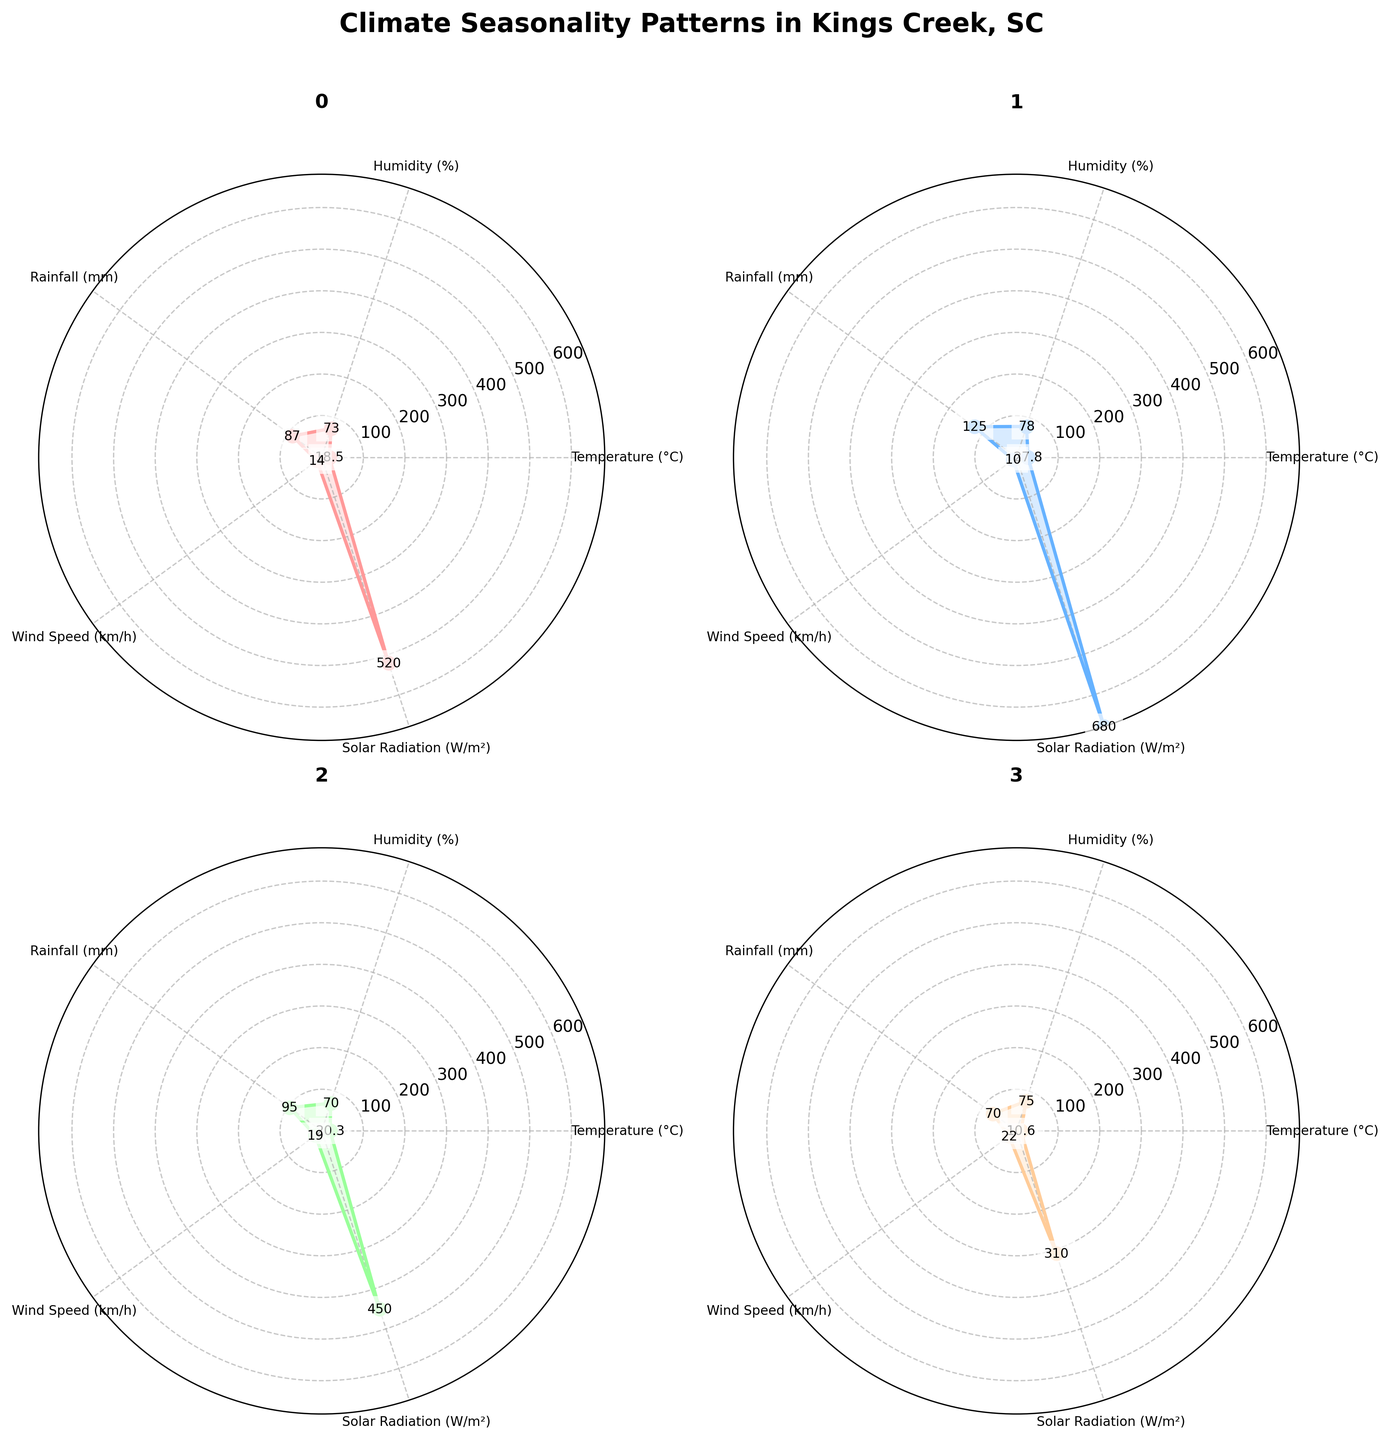What's the highest temperature across all seasons? By looking at the temperature values in each subplot, we can see the highest temperature is during Summer with a value of 27.8 °C.
Answer: 27.8 °C During which season is the humidity the lowest? To find the season with the lowest humidity, we compare the humidity values in each subplot. Autumn has the lowest humidity at 70%.
Answer: Autumn What is the difference in rainfall between Summer and Winter? The rainfall in Summer is 125 mm and in Winter, it is 70 mm. Subtract the Winter rainfall from the Summer rainfall: 125 mm - 70 mm = 55 mm.
Answer: 55 mm Which season has the highest solar radiation, and what is its value? Solar radiation is highest during Summer with a value of 680 W/m², as shown in the respective subplot.
Answer: Summer, 680 W/m² What is the average wind speed across all seasons? To calculate the average wind speed, add the wind speeds of all seasons and divide by the number of seasons: (14 + 10 + 19 + 22) / 4 = 65 / 4 = 16.25 km/h.
Answer: 16.25 km/h Between Spring and Autumn, which season has higher humidity and by how much? Spring has a humidity of 73% while Autumn has a humidity of 70%. Subtract Autumn's humidity from Spring's: 73% - 70% = 3%.
Answer: Spring by 3% What is the average temperature difference between Summer and Winter? The temperature in Summer is 27.8 °C and in Winter it is 10.6 °C. The difference is 27.8 - 10.6 = 17.2 °C. Divide this by 2 to find the average difference: 17.2 / 2 = 8.6 °C.
Answer: 8.6 °C Which variable shows the greatest variability across different seasons? By comparing the ranges of each variable across all seasons, humidity has the smallest range (70%-78% which is 8), temperature ranges from 10.6 to 27.8 (17.2), rainfall from 70 to 125 (55), wind speed from 10 to 22 (12), and solar radiation from 310 to 680 (370). Thus, solar radiation shows the greatest variability.
Answer: Solar radiation 